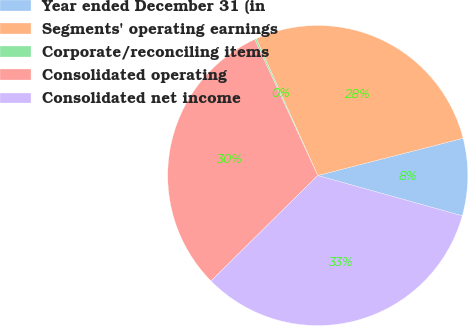<chart> <loc_0><loc_0><loc_500><loc_500><pie_chart><fcel>Year ended December 31 (in<fcel>Segments' operating earnings<fcel>Corporate/reconciling items<fcel>Consolidated operating<fcel>Consolidated net income<nl><fcel>8.32%<fcel>27.73%<fcel>0.18%<fcel>30.5%<fcel>33.27%<nl></chart> 